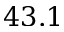Convert formula to latex. <formula><loc_0><loc_0><loc_500><loc_500>4 3 . 1</formula> 